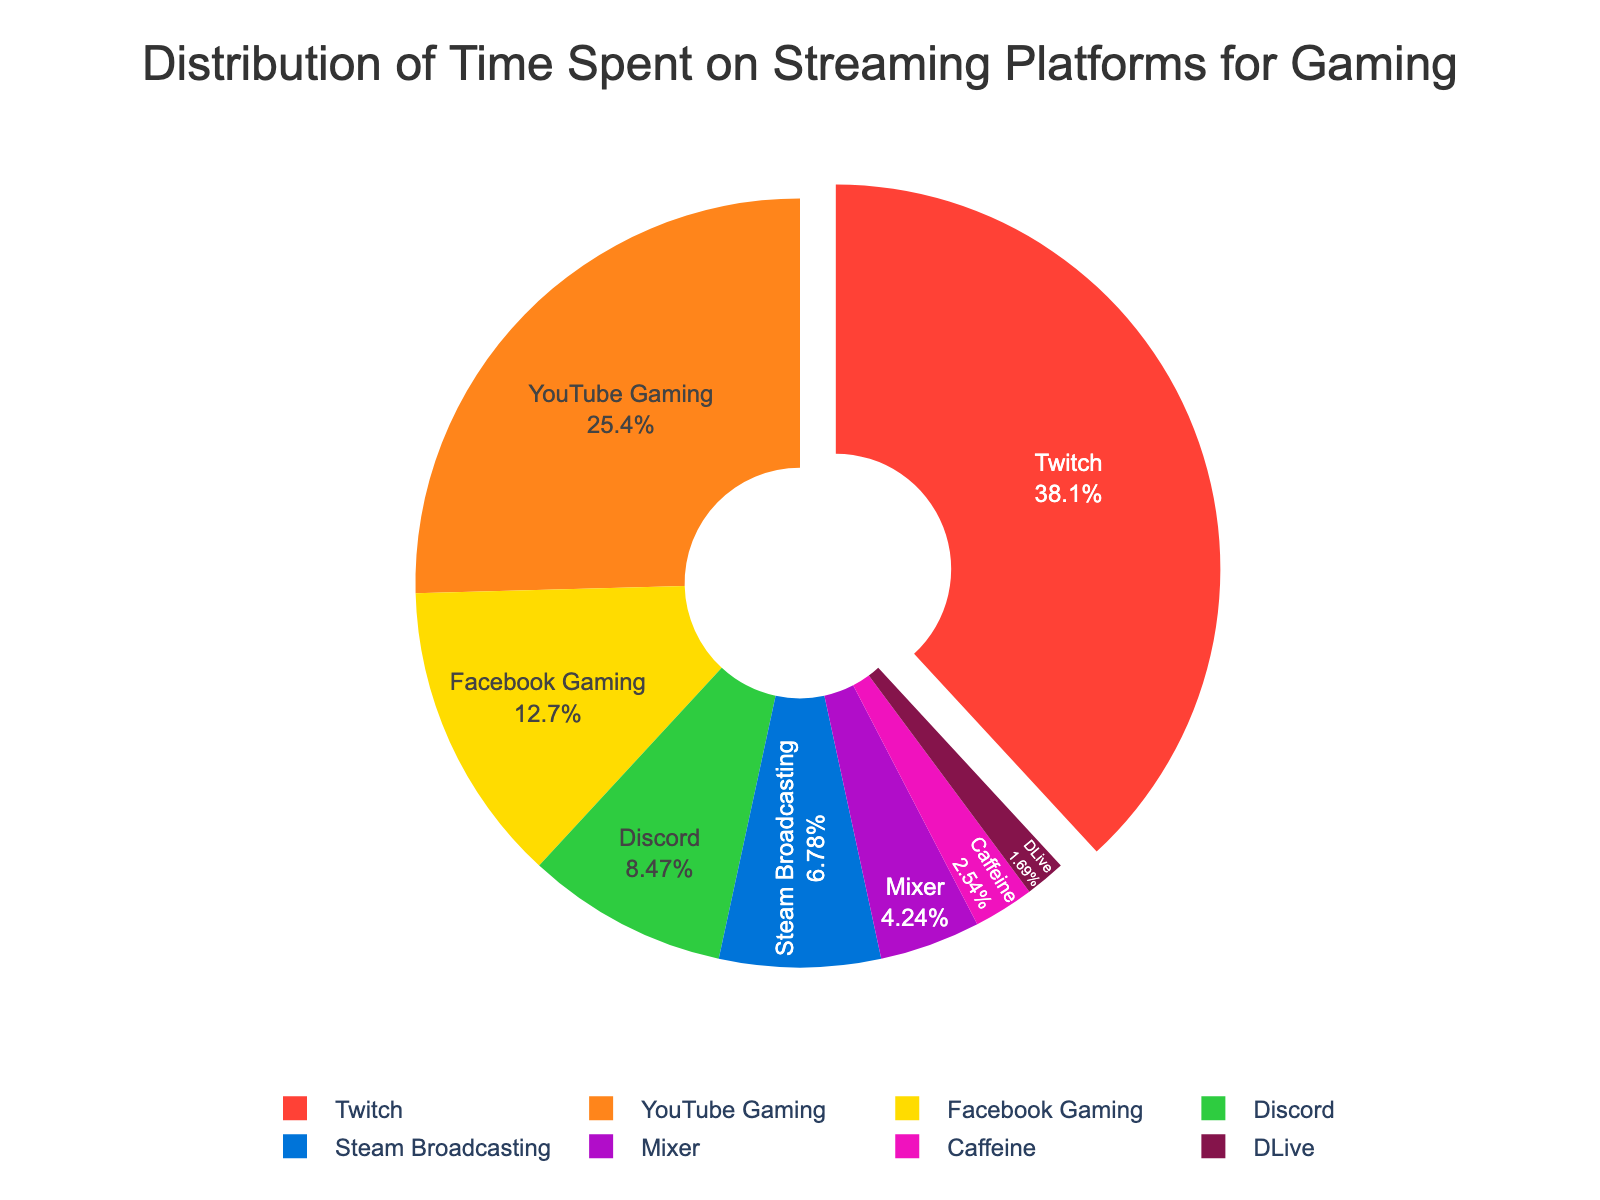What's the total time spent on Twitch and YouTube Gaming combined? Sum the time spent on Twitch (45 hours) and YouTube Gaming (30 hours): 45 + 30 = 75 hours
Answer: 75 hours Which platform has the least amount of time spent and how much time is it? Look at the smallest section of the pie chart, which corresponds to DLive with 2 hours.
Answer: DLive, 2 hours Is the time spent on Discord more or less than the time spent on Steam Broadcasting? Compare the hours spent on Discord (10 hours) with those on Steam Broadcasting (8 hours): 10 > 8
Answer: More What is the difference in hours between Facebook Gaming and Mixer? Subtract the hours of Mixer (5) from Facebook Gaming (15): 15 - 5 = 10 hours
Answer: 10 hours If you combine the time spent on Discord and Facebook Gaming, does it exceed the time spent on YouTube Gaming? Sum the time for Discord (10 hours) and Facebook Gaming (15 hours) and compare with YouTube Gaming (30 hours): 10 + 15 = 25; 25 < 30
Answer: No Which platform has approximately a third of the time spent on Twitch? Calculate one-third of Twitch's time (45): 45 / 3 = 15; This matches Facebook Gaming, which has 15 hours.
Answer: Facebook Gaming What percentage of total time is spent on Mixer? Calculate the percentage: (5 hours spent on Mixer / total hours 118) * 100 ≈ 4.24%
Answer: ~4.24% Name the platforms where the total time spent is less than 10 hours. Identify platforms with less than 10 hours: Steam Broadcasting (8), Mixer (5), Caffeine (3), DLive (2)
Answer: Steam Broadcasting, Mixer, Caffeine, DLive Which color represents the platform with the second-highest time spent? Identify the second-highest time (YouTube Gaming, 30 hours) and find its color in the pie chart: It is likely represented by orange.
Answer: Orange Does the combined time spent on Caffeine and Mixer surpass the time spent on Discord? Calculate: Caffeine (3 hours) + Mixer (5 hours) = 8 hours; Compare with Discord (10 hours): 8 < 10
Answer: No 